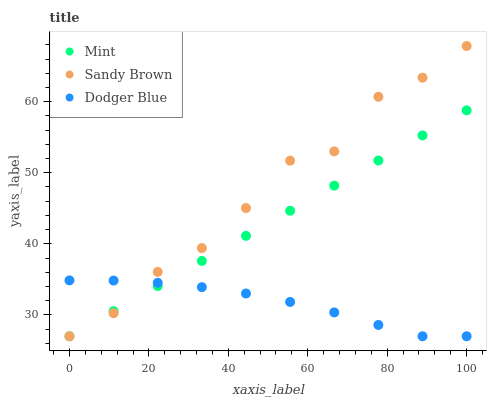Does Dodger Blue have the minimum area under the curve?
Answer yes or no. Yes. Does Sandy Brown have the maximum area under the curve?
Answer yes or no. Yes. Does Mint have the minimum area under the curve?
Answer yes or no. No. Does Mint have the maximum area under the curve?
Answer yes or no. No. Is Mint the smoothest?
Answer yes or no. Yes. Is Sandy Brown the roughest?
Answer yes or no. Yes. Is Dodger Blue the smoothest?
Answer yes or no. No. Is Dodger Blue the roughest?
Answer yes or no. No. Does Sandy Brown have the lowest value?
Answer yes or no. Yes. Does Sandy Brown have the highest value?
Answer yes or no. Yes. Does Mint have the highest value?
Answer yes or no. No. Does Dodger Blue intersect Mint?
Answer yes or no. Yes. Is Dodger Blue less than Mint?
Answer yes or no. No. Is Dodger Blue greater than Mint?
Answer yes or no. No. 